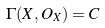Convert formula to latex. <formula><loc_0><loc_0><loc_500><loc_500>\Gamma ( X , O _ { X } ) = C</formula> 